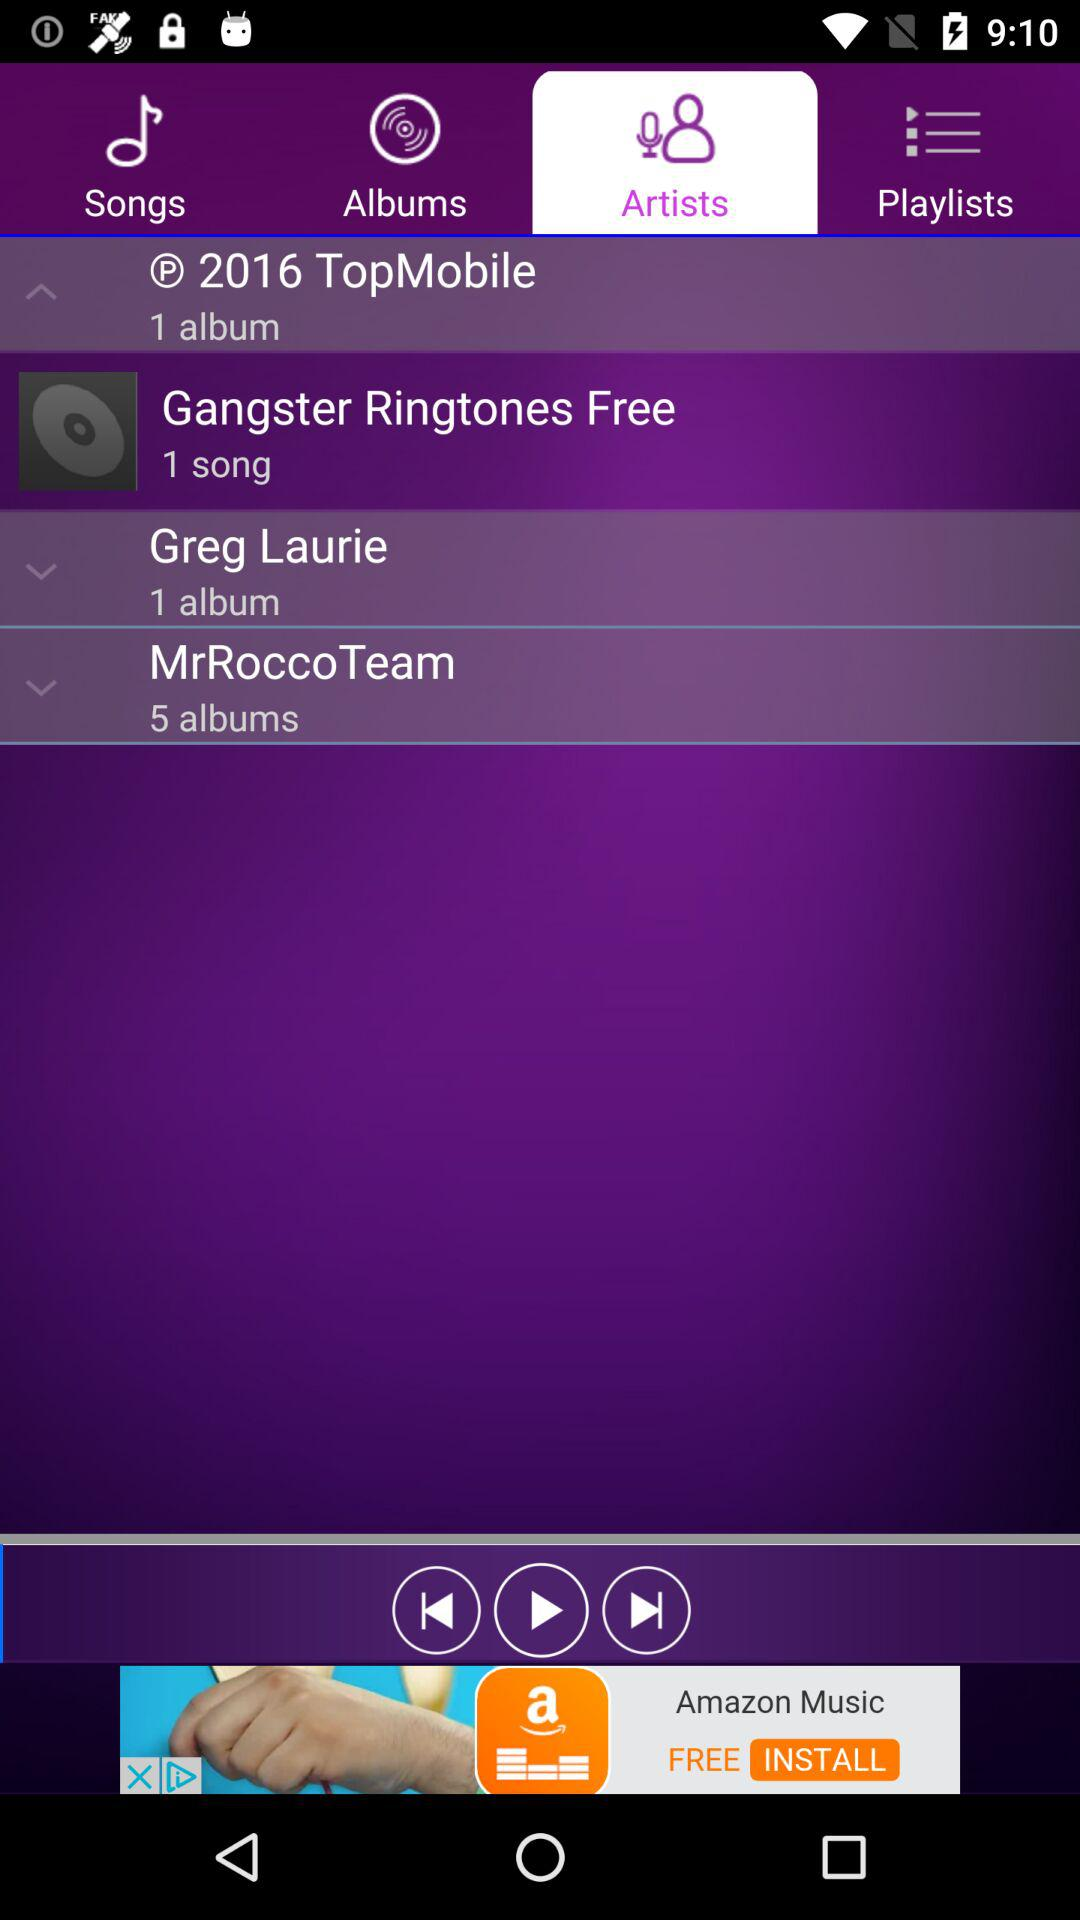Which tab is selected? The selected tab is "Artists". 